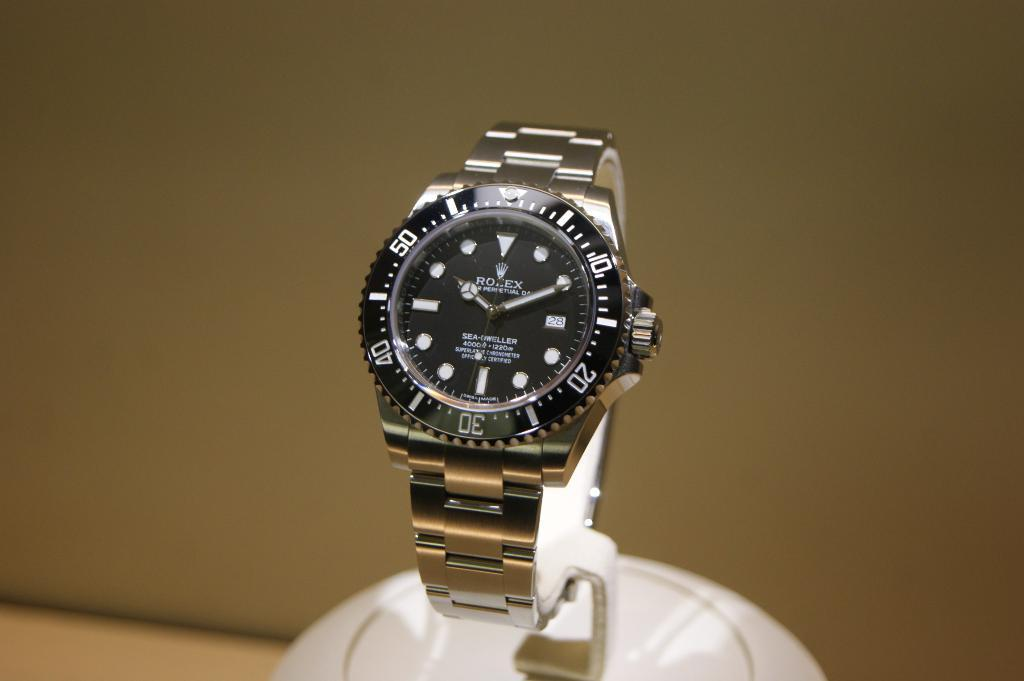<image>
Offer a succinct explanation of the picture presented. A gold ROLEX watch with a black face and white accents 